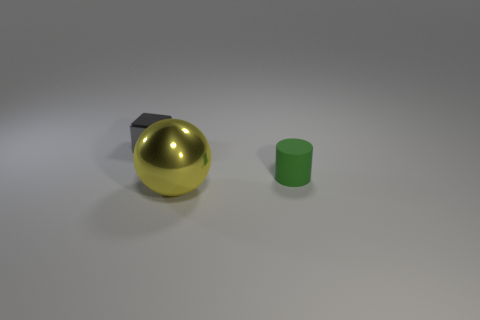Add 1 yellow metallic objects. How many objects exist? 4 Subtract all cylinders. How many objects are left? 2 Subtract all large shiny things. Subtract all gray blocks. How many objects are left? 1 Add 3 large metallic objects. How many large metallic objects are left? 4 Add 3 green rubber cylinders. How many green rubber cylinders exist? 4 Subtract 0 brown blocks. How many objects are left? 3 